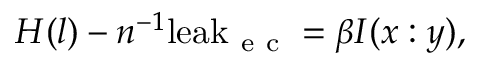Convert formula to latex. <formula><loc_0><loc_0><loc_500><loc_500>H ( l ) - n ^ { - 1 } l e a k _ { e c } = \beta I ( x \colon y ) ,</formula> 